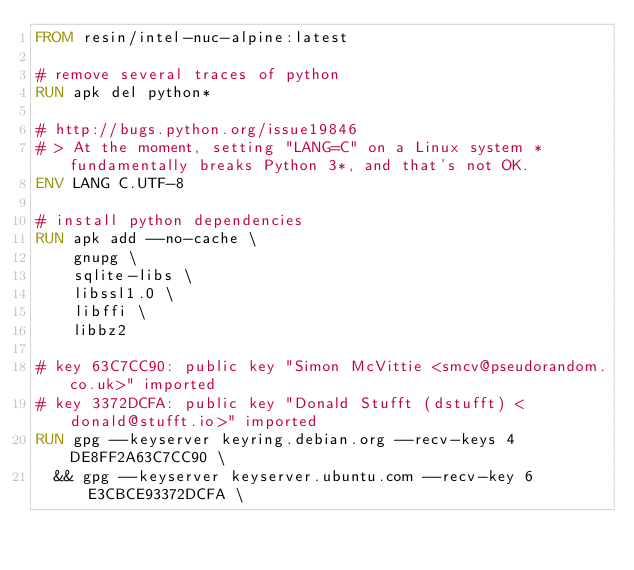Convert code to text. <code><loc_0><loc_0><loc_500><loc_500><_Dockerfile_>FROM resin/intel-nuc-alpine:latest

# remove several traces of python
RUN apk del python*

# http://bugs.python.org/issue19846
# > At the moment, setting "LANG=C" on a Linux system *fundamentally breaks Python 3*, and that's not OK.
ENV LANG C.UTF-8

# install python dependencies
RUN apk add --no-cache \
		gnupg \
		sqlite-libs \
		libssl1.0 \
		libffi \
		libbz2

# key 63C7CC90: public key "Simon McVittie <smcv@pseudorandom.co.uk>" imported
# key 3372DCFA: public key "Donald Stufft (dstufft) <donald@stufft.io>" imported
RUN gpg --keyserver keyring.debian.org --recv-keys 4DE8FF2A63C7CC90 \
	&& gpg --keyserver keyserver.ubuntu.com --recv-key 6E3CBCE93372DCFA \</code> 